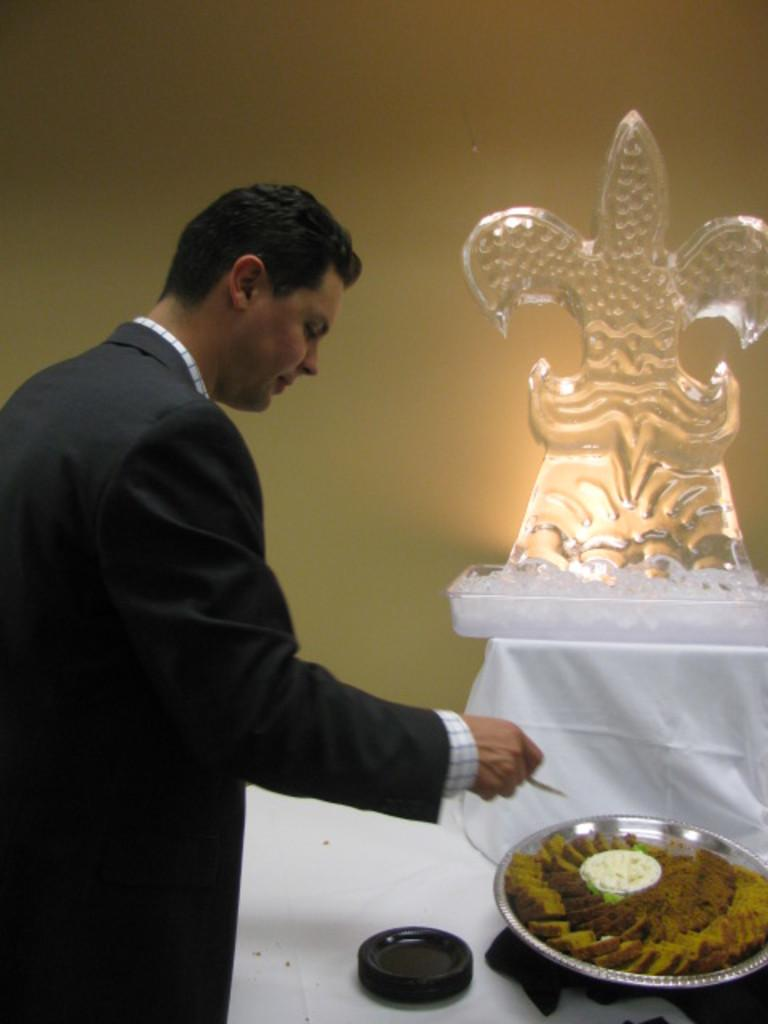Who is present in the image? There is a man in the image. What is the man wearing? The man is wearing a black suit. What is in front of the man? There is an idol and a tray of sweets in front of the man. What can be seen in the background of the image? There is a wall in the background of the image. Can you see a frog hopping on the tray of sweets in the image? No, there is no frog present in the image. What type of tool is the man using to dig in the image? There is no tool or digging activity depicted in the image. 